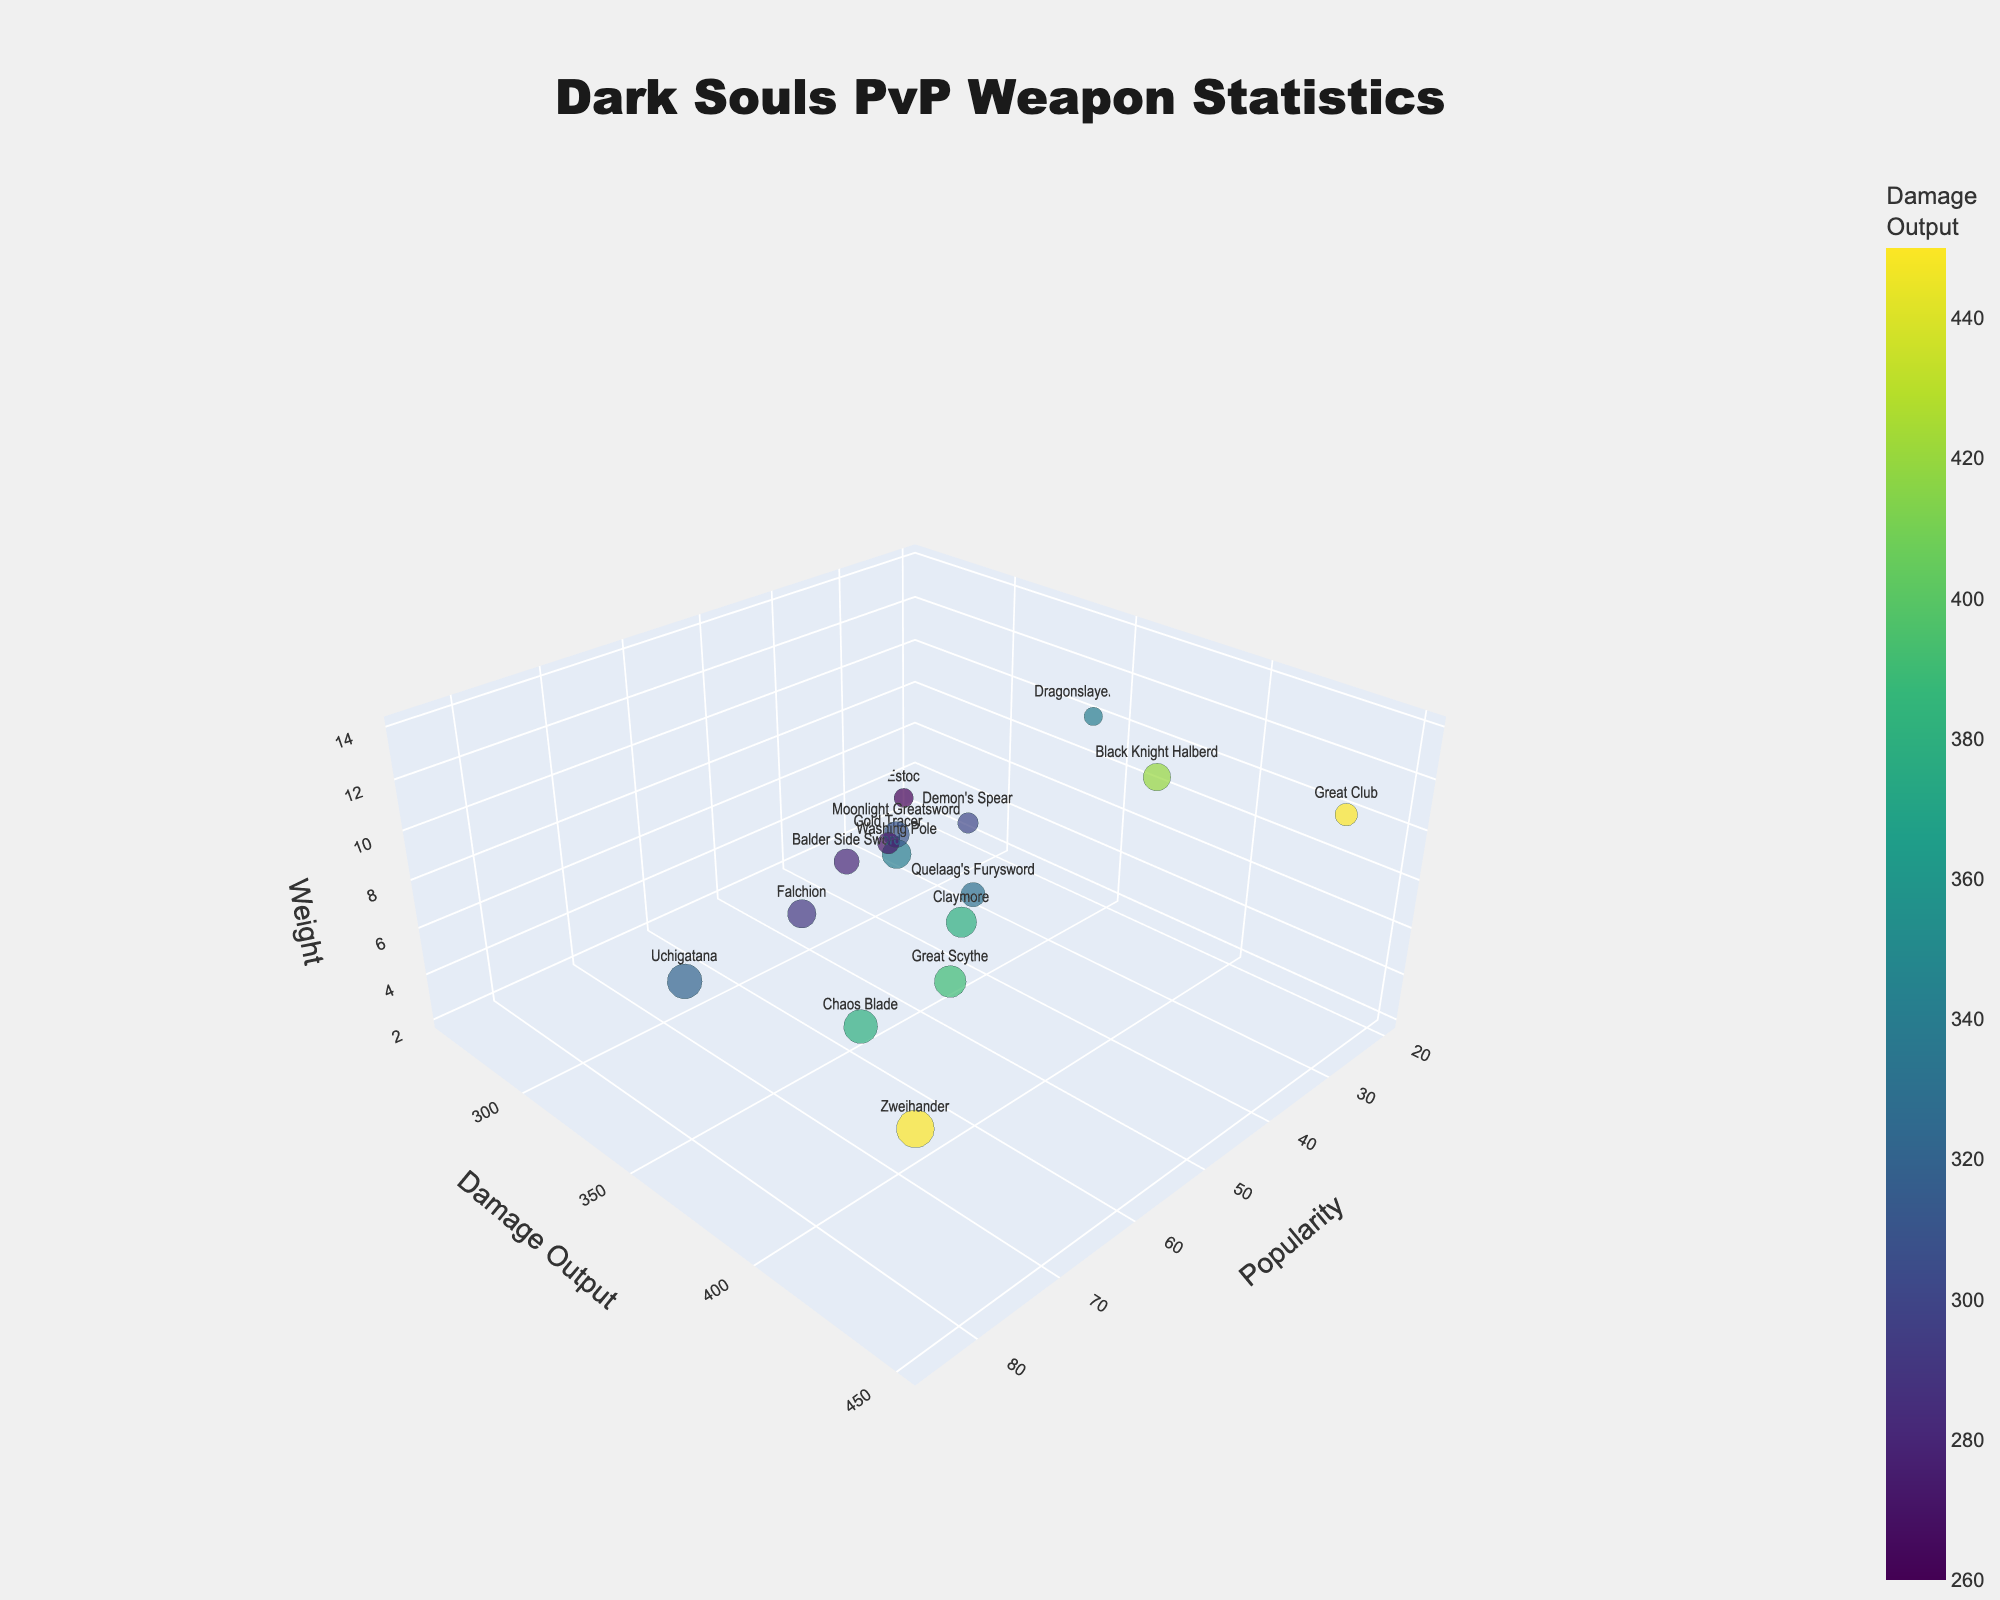What's the title of the figure? The title is located at the top center of the figure, formatted in a bold and readable style. The title provides a summary of what the figure represents.
Answer: "Dark Souls PvP Weapon Statistics" How many data points are there in the figure? Each bubble represents a data point corresponding to a specific weapon. Counting all the bubbles provides the number of data points.
Answer: 16 Which weapon has the highest popularity? The weapon with the highest popularity is represented by the largest bubble along the x-axis, where the bubbles are sorted by popularity.
Answer: Zweihander Which weapon has the highest damage output? The bubble with the highest value on the y-axis corresponds to the weapon with the highest damage output. Identifying this point on the y-axis reveals the weapon.
Answer: Zweihander and Great Club (both 450) What is the weight of the most popular weapon? The most popular weapon is the one with the largest bubble size on the chart. By locating this bubble and checking its position on the z-axis, the weight can be determined.
Answer: 10 Which weapon has the lowest weight? The weapon with the lowest weight would be represented by the bubble positioned at the lowest point on the z-axis.
Answer: Gold Tracer (2) Compare the popularity of Zweihander and Uchigatana. Which one is more popular? To determine which weapon is more popular, locate the bubbles for Zweihander and Uchigatana and compare their sizes or their positions on the x-axis.
Answer: Zweihander Which weapon has a higher damage output, Great Scythe or Moonlight Greatsword? Locate the bubbles for Great Scythe and Moonlight Greatsword and compare their positions on the y-axis, indicating damage output.
Answer: Great Scythe What are the average popularity and average damage output of the Claymore and Washing Pole combined? First, find the values of popularity and damage output for both weapons: Claymore (55, 380) and Washing Pole (50, 340). Compute the averages for these values:
   - Average Popularity: (55 + 50) / 2 = 52.5
   - Average Damage Output: (380 + 340) / 2 = 360
Answer: Average Popularity: 52.5, Average Damage Output: 360 Which weapon has the closest combination of popularity and damage output? To find this, look for a weapon whose bubble is positioned where the values of popularity (x-axis) and damage output (y-axis) are closest.
Answer: Uchigatana (72, 320) 